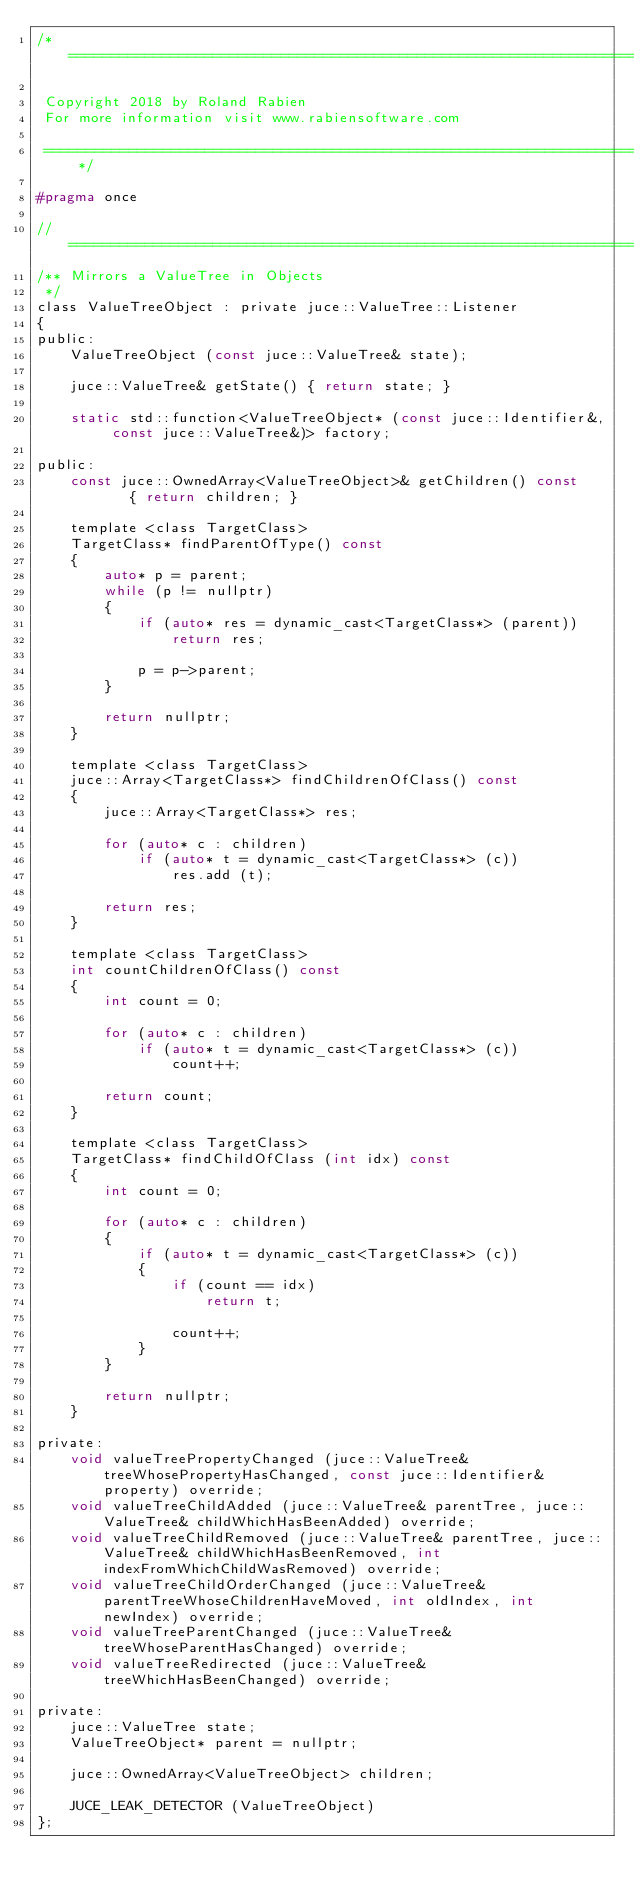<code> <loc_0><loc_0><loc_500><loc_500><_C_>/*==============================================================================

 Copyright 2018 by Roland Rabien
 For more information visit www.rabiensoftware.com

 ==============================================================================*/

#pragma once

//==============================================================================
/** Mirrors a ValueTree in Objects
 */
class ValueTreeObject : private juce::ValueTree::Listener
{
public:
    ValueTreeObject (const juce::ValueTree& state);

    juce::ValueTree& getState() { return state; }

    static std::function<ValueTreeObject* (const juce::Identifier&, const juce::ValueTree&)> factory;

public:
    const juce::OwnedArray<ValueTreeObject>& getChildren() const    { return children; }

    template <class TargetClass>
    TargetClass* findParentOfType() const
    {
        auto* p = parent;
        while (p != nullptr)
        {
            if (auto* res = dynamic_cast<TargetClass*> (parent))
                return res;

            p = p->parent;
        }

        return nullptr;
    }

    template <class TargetClass>
    juce::Array<TargetClass*> findChildrenOfClass() const
    {
        juce::Array<TargetClass*> res;

        for (auto* c : children)
            if (auto* t = dynamic_cast<TargetClass*> (c))
                res.add (t);

        return res;
    }

    template <class TargetClass>
    int countChildrenOfClass() const
    {
        int count = 0;

        for (auto* c : children)
            if (auto* t = dynamic_cast<TargetClass*> (c))
                count++;

        return count;
    }

    template <class TargetClass>
    TargetClass* findChildOfClass (int idx) const
    {
        int count = 0;

        for (auto* c : children)
        {
            if (auto* t = dynamic_cast<TargetClass*> (c))
            {
                if (count == idx)
                    return t;

                count++;
            }
        }

        return nullptr;
    }

private:
    void valueTreePropertyChanged (juce::ValueTree& treeWhosePropertyHasChanged, const juce::Identifier& property) override;
    void valueTreeChildAdded (juce::ValueTree& parentTree, juce::ValueTree& childWhichHasBeenAdded) override;
    void valueTreeChildRemoved (juce::ValueTree& parentTree, juce::ValueTree& childWhichHasBeenRemoved, int indexFromWhichChildWasRemoved) override;
    void valueTreeChildOrderChanged (juce::ValueTree& parentTreeWhoseChildrenHaveMoved, int oldIndex, int newIndex) override;
    void valueTreeParentChanged (juce::ValueTree& treeWhoseParentHasChanged) override;
    void valueTreeRedirected (juce::ValueTree& treeWhichHasBeenChanged) override;

private:
    juce::ValueTree state;
    ValueTreeObject* parent = nullptr;

    juce::OwnedArray<ValueTreeObject> children;

    JUCE_LEAK_DETECTOR (ValueTreeObject)
};
</code> 